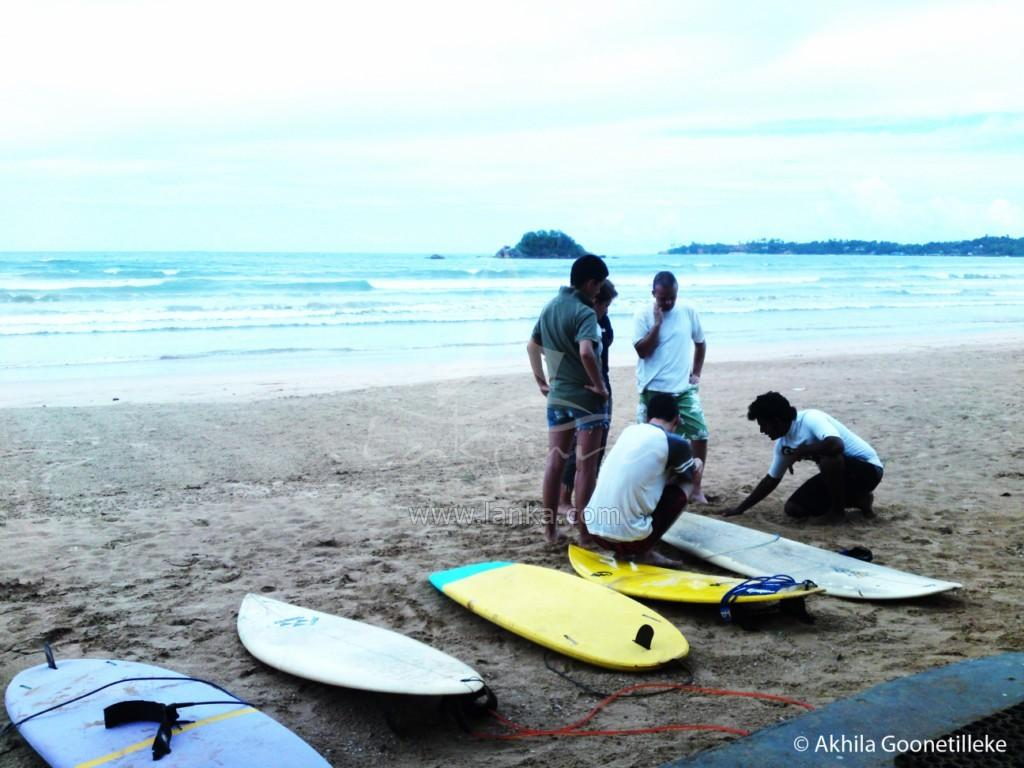How many people are in the image? There are people in the image, but the exact number is not specified. What are the people doing in the image? Some people are standing, while others are sitting on the ground. What objects are on the ground in the image? There are surfboards on the ground. What can be seen in the background of the image? There is an ocean visible in the background of the image. How many lizards are attempting to climb the surfboards in the image? There are no lizards present in the image, and therefore no such activity can be observed. 